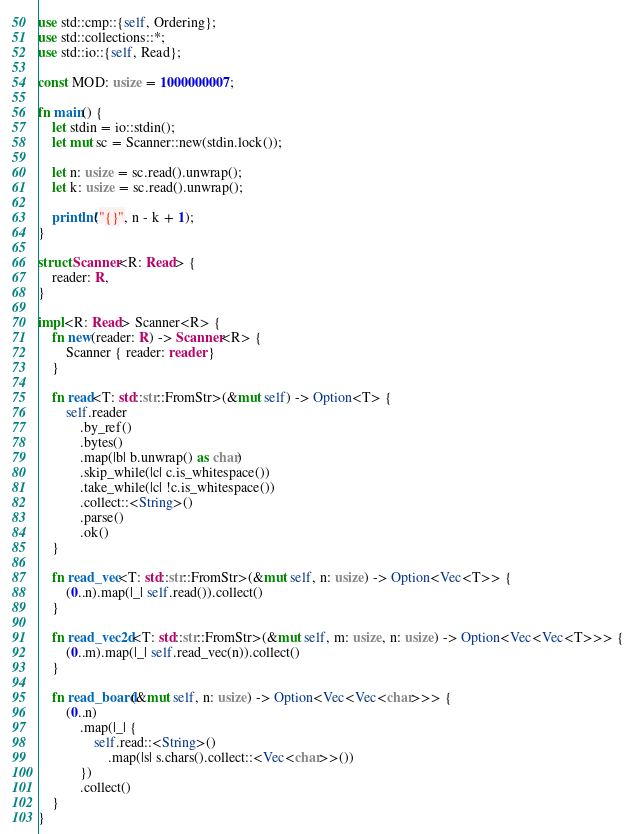<code> <loc_0><loc_0><loc_500><loc_500><_Rust_>use std::cmp::{self, Ordering};
use std::collections::*;
use std::io::{self, Read};

const MOD: usize = 1000000007;

fn main() {
    let stdin = io::stdin();
    let mut sc = Scanner::new(stdin.lock());

    let n: usize = sc.read().unwrap();
    let k: usize = sc.read().unwrap();

    println!("{}", n - k + 1);
}

struct Scanner<R: Read> {
    reader: R,
}

impl<R: Read> Scanner<R> {
    fn new(reader: R) -> Scanner<R> {
        Scanner { reader: reader }
    }

    fn read<T: std::str::FromStr>(&mut self) -> Option<T> {
        self.reader
            .by_ref()
            .bytes()
            .map(|b| b.unwrap() as char)
            .skip_while(|c| c.is_whitespace())
            .take_while(|c| !c.is_whitespace())
            .collect::<String>()
            .parse()
            .ok()
    }

    fn read_vec<T: std::str::FromStr>(&mut self, n: usize) -> Option<Vec<T>> {
        (0..n).map(|_| self.read()).collect()
    }

    fn read_vec2d<T: std::str::FromStr>(&mut self, m: usize, n: usize) -> Option<Vec<Vec<T>>> {
        (0..m).map(|_| self.read_vec(n)).collect()
    }

    fn read_board(&mut self, n: usize) -> Option<Vec<Vec<char>>> {
        (0..n)
            .map(|_| {
                self.read::<String>()
                    .map(|s| s.chars().collect::<Vec<char>>())
            })
            .collect()
    }
}
</code> 